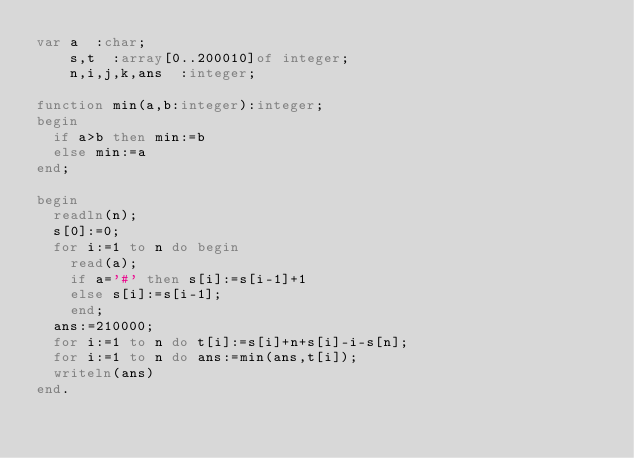Convert code to text. <code><loc_0><loc_0><loc_500><loc_500><_Pascal_>var a  :char;
    s,t  :array[0..200010]of integer;
    n,i,j,k,ans  :integer;
    
function min(a,b:integer):integer;
begin
  if a>b then min:=b
  else min:=a
end;

begin
  readln(n);
  s[0]:=0;
  for i:=1 to n do begin
    read(a);
    if a='#' then s[i]:=s[i-1]+1
    else s[i]:=s[i-1];
    end;
  ans:=210000;
  for i:=1 to n do t[i]:=s[i]+n+s[i]-i-s[n];
  for i:=1 to n do ans:=min(ans,t[i]);
  writeln(ans)
end.
</code> 